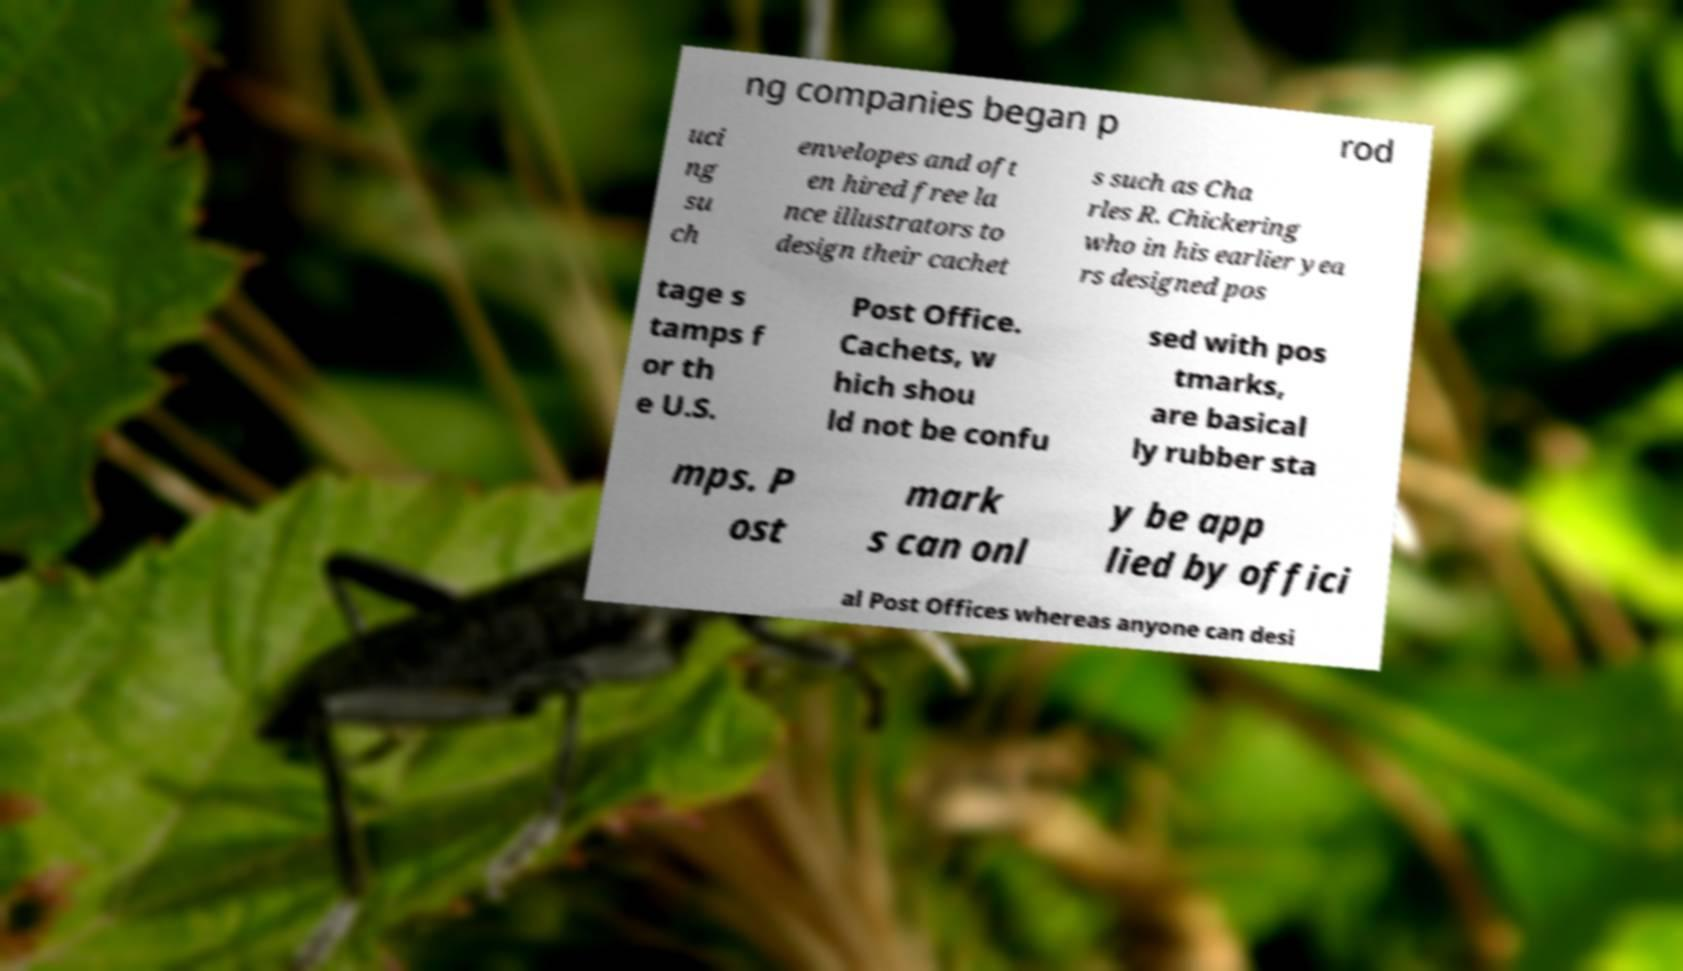I need the written content from this picture converted into text. Can you do that? ng companies began p rod uci ng su ch envelopes and oft en hired free la nce illustrators to design their cachet s such as Cha rles R. Chickering who in his earlier yea rs designed pos tage s tamps f or th e U.S. Post Office. Cachets, w hich shou ld not be confu sed with pos tmarks, are basical ly rubber sta mps. P ost mark s can onl y be app lied by offici al Post Offices whereas anyone can desi 